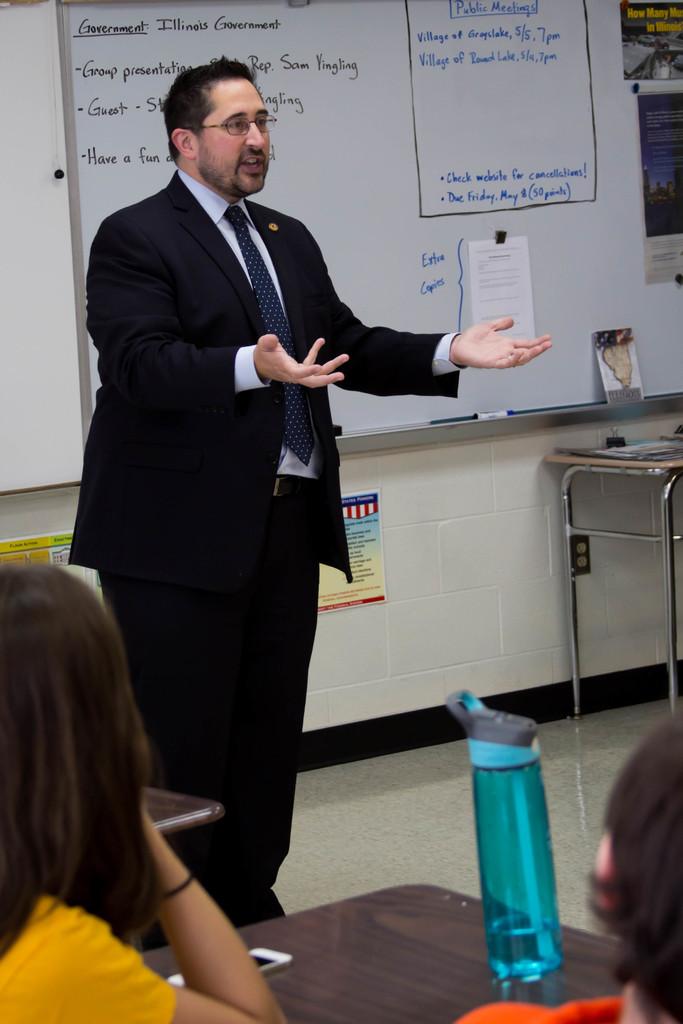What state government are they talking about?
Give a very brief answer. Illinois. 